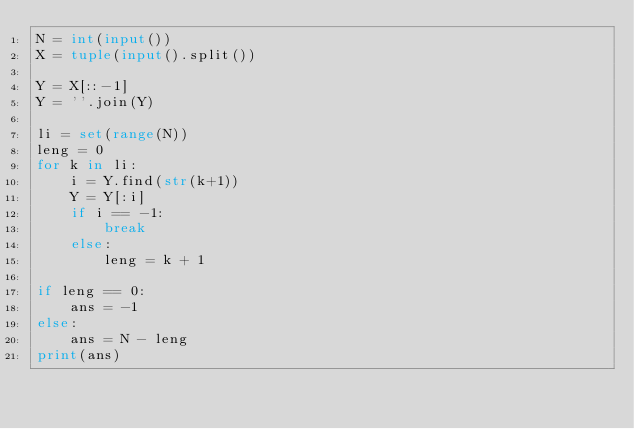<code> <loc_0><loc_0><loc_500><loc_500><_Python_>N = int(input())
X = tuple(input().split())

Y = X[::-1]
Y = ''.join(Y)

li = set(range(N))
leng = 0
for k in li:
    i = Y.find(str(k+1))
    Y = Y[:i]
    if i == -1:
        break
    else:
        leng = k + 1

if leng == 0:
    ans = -1
else:
    ans = N - leng
print(ans)
</code> 